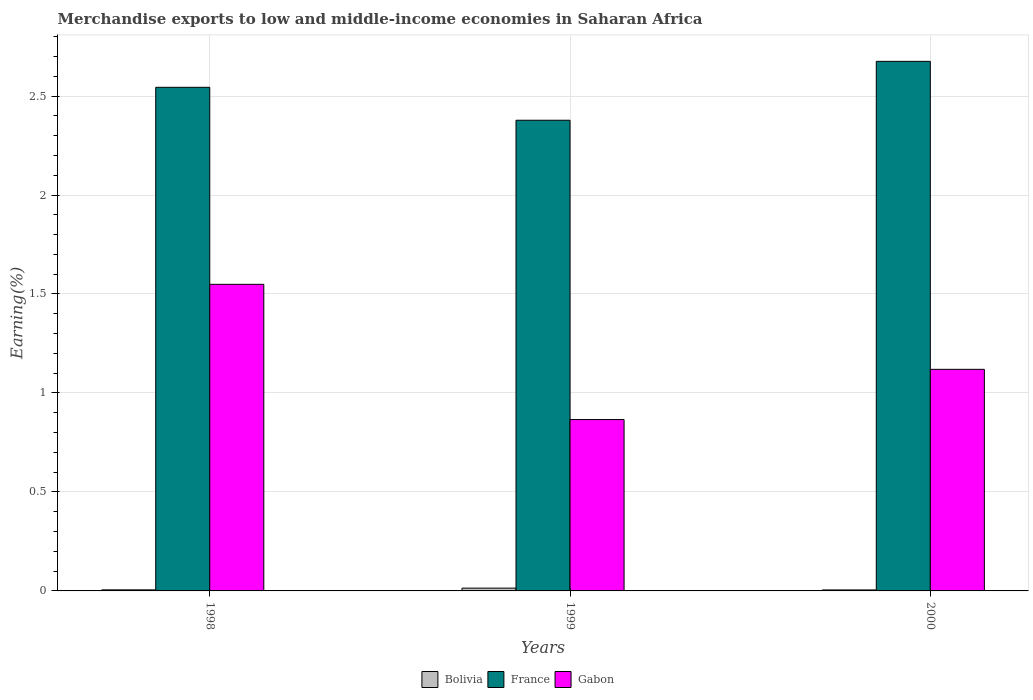How many groups of bars are there?
Keep it short and to the point. 3. How many bars are there on the 2nd tick from the right?
Provide a succinct answer. 3. What is the label of the 2nd group of bars from the left?
Give a very brief answer. 1999. In how many cases, is the number of bars for a given year not equal to the number of legend labels?
Provide a short and direct response. 0. What is the percentage of amount earned from merchandise exports in France in 1999?
Provide a short and direct response. 2.38. Across all years, what is the maximum percentage of amount earned from merchandise exports in Bolivia?
Give a very brief answer. 0.01. Across all years, what is the minimum percentage of amount earned from merchandise exports in France?
Your answer should be very brief. 2.38. In which year was the percentage of amount earned from merchandise exports in Bolivia maximum?
Offer a very short reply. 1999. In which year was the percentage of amount earned from merchandise exports in Gabon minimum?
Make the answer very short. 1999. What is the total percentage of amount earned from merchandise exports in Bolivia in the graph?
Provide a succinct answer. 0.02. What is the difference between the percentage of amount earned from merchandise exports in France in 1999 and that in 2000?
Offer a terse response. -0.3. What is the difference between the percentage of amount earned from merchandise exports in France in 2000 and the percentage of amount earned from merchandise exports in Gabon in 1998?
Ensure brevity in your answer.  1.13. What is the average percentage of amount earned from merchandise exports in Gabon per year?
Offer a terse response. 1.18. In the year 1998, what is the difference between the percentage of amount earned from merchandise exports in Gabon and percentage of amount earned from merchandise exports in Bolivia?
Your answer should be very brief. 1.54. What is the ratio of the percentage of amount earned from merchandise exports in France in 1998 to that in 1999?
Offer a terse response. 1.07. What is the difference between the highest and the second highest percentage of amount earned from merchandise exports in France?
Your answer should be very brief. 0.13. What is the difference between the highest and the lowest percentage of amount earned from merchandise exports in Gabon?
Your answer should be compact. 0.68. In how many years, is the percentage of amount earned from merchandise exports in Bolivia greater than the average percentage of amount earned from merchandise exports in Bolivia taken over all years?
Provide a succinct answer. 1. Is the sum of the percentage of amount earned from merchandise exports in France in 1999 and 2000 greater than the maximum percentage of amount earned from merchandise exports in Bolivia across all years?
Ensure brevity in your answer.  Yes. What does the 1st bar from the left in 1999 represents?
Your answer should be very brief. Bolivia. What does the 2nd bar from the right in 2000 represents?
Give a very brief answer. France. Is it the case that in every year, the sum of the percentage of amount earned from merchandise exports in France and percentage of amount earned from merchandise exports in Gabon is greater than the percentage of amount earned from merchandise exports in Bolivia?
Give a very brief answer. Yes. How many years are there in the graph?
Provide a succinct answer. 3. Does the graph contain any zero values?
Offer a very short reply. No. How many legend labels are there?
Your answer should be compact. 3. How are the legend labels stacked?
Ensure brevity in your answer.  Horizontal. What is the title of the graph?
Ensure brevity in your answer.  Merchandise exports to low and middle-income economies in Saharan Africa. What is the label or title of the Y-axis?
Give a very brief answer. Earning(%). What is the Earning(%) of Bolivia in 1998?
Offer a very short reply. 0.01. What is the Earning(%) in France in 1998?
Provide a short and direct response. 2.54. What is the Earning(%) of Gabon in 1998?
Provide a short and direct response. 1.55. What is the Earning(%) in Bolivia in 1999?
Provide a short and direct response. 0.01. What is the Earning(%) in France in 1999?
Keep it short and to the point. 2.38. What is the Earning(%) in Gabon in 1999?
Your response must be concise. 0.87. What is the Earning(%) in Bolivia in 2000?
Offer a terse response. 0.01. What is the Earning(%) of France in 2000?
Your answer should be compact. 2.68. What is the Earning(%) of Gabon in 2000?
Ensure brevity in your answer.  1.12. Across all years, what is the maximum Earning(%) of Bolivia?
Keep it short and to the point. 0.01. Across all years, what is the maximum Earning(%) in France?
Give a very brief answer. 2.68. Across all years, what is the maximum Earning(%) of Gabon?
Provide a succinct answer. 1.55. Across all years, what is the minimum Earning(%) in Bolivia?
Your answer should be compact. 0.01. Across all years, what is the minimum Earning(%) in France?
Provide a short and direct response. 2.38. Across all years, what is the minimum Earning(%) in Gabon?
Your answer should be compact. 0.87. What is the total Earning(%) of Bolivia in the graph?
Offer a very short reply. 0.02. What is the total Earning(%) of France in the graph?
Your answer should be very brief. 7.6. What is the total Earning(%) of Gabon in the graph?
Your response must be concise. 3.53. What is the difference between the Earning(%) in Bolivia in 1998 and that in 1999?
Offer a terse response. -0.01. What is the difference between the Earning(%) in France in 1998 and that in 1999?
Give a very brief answer. 0.17. What is the difference between the Earning(%) in Gabon in 1998 and that in 1999?
Give a very brief answer. 0.68. What is the difference between the Earning(%) in France in 1998 and that in 2000?
Offer a terse response. -0.13. What is the difference between the Earning(%) of Gabon in 1998 and that in 2000?
Keep it short and to the point. 0.43. What is the difference between the Earning(%) in Bolivia in 1999 and that in 2000?
Your answer should be compact. 0.01. What is the difference between the Earning(%) in France in 1999 and that in 2000?
Give a very brief answer. -0.3. What is the difference between the Earning(%) of Gabon in 1999 and that in 2000?
Offer a terse response. -0.25. What is the difference between the Earning(%) of Bolivia in 1998 and the Earning(%) of France in 1999?
Keep it short and to the point. -2.37. What is the difference between the Earning(%) in Bolivia in 1998 and the Earning(%) in Gabon in 1999?
Ensure brevity in your answer.  -0.86. What is the difference between the Earning(%) in France in 1998 and the Earning(%) in Gabon in 1999?
Keep it short and to the point. 1.68. What is the difference between the Earning(%) in Bolivia in 1998 and the Earning(%) in France in 2000?
Make the answer very short. -2.67. What is the difference between the Earning(%) of Bolivia in 1998 and the Earning(%) of Gabon in 2000?
Offer a very short reply. -1.11. What is the difference between the Earning(%) in France in 1998 and the Earning(%) in Gabon in 2000?
Your answer should be compact. 1.42. What is the difference between the Earning(%) in Bolivia in 1999 and the Earning(%) in France in 2000?
Your response must be concise. -2.66. What is the difference between the Earning(%) of Bolivia in 1999 and the Earning(%) of Gabon in 2000?
Provide a short and direct response. -1.11. What is the difference between the Earning(%) in France in 1999 and the Earning(%) in Gabon in 2000?
Provide a succinct answer. 1.26. What is the average Earning(%) in Bolivia per year?
Offer a terse response. 0.01. What is the average Earning(%) in France per year?
Your answer should be compact. 2.53. What is the average Earning(%) in Gabon per year?
Offer a very short reply. 1.18. In the year 1998, what is the difference between the Earning(%) in Bolivia and Earning(%) in France?
Ensure brevity in your answer.  -2.54. In the year 1998, what is the difference between the Earning(%) of Bolivia and Earning(%) of Gabon?
Offer a terse response. -1.54. In the year 1998, what is the difference between the Earning(%) in France and Earning(%) in Gabon?
Make the answer very short. 1. In the year 1999, what is the difference between the Earning(%) of Bolivia and Earning(%) of France?
Give a very brief answer. -2.36. In the year 1999, what is the difference between the Earning(%) of Bolivia and Earning(%) of Gabon?
Your answer should be very brief. -0.85. In the year 1999, what is the difference between the Earning(%) in France and Earning(%) in Gabon?
Make the answer very short. 1.51. In the year 2000, what is the difference between the Earning(%) of Bolivia and Earning(%) of France?
Make the answer very short. -2.67. In the year 2000, what is the difference between the Earning(%) in Bolivia and Earning(%) in Gabon?
Your answer should be compact. -1.11. In the year 2000, what is the difference between the Earning(%) of France and Earning(%) of Gabon?
Your response must be concise. 1.56. What is the ratio of the Earning(%) in Bolivia in 1998 to that in 1999?
Provide a succinct answer. 0.39. What is the ratio of the Earning(%) of France in 1998 to that in 1999?
Offer a terse response. 1.07. What is the ratio of the Earning(%) in Gabon in 1998 to that in 1999?
Offer a very short reply. 1.79. What is the ratio of the Earning(%) of Bolivia in 1998 to that in 2000?
Provide a succinct answer. 1.08. What is the ratio of the Earning(%) of France in 1998 to that in 2000?
Make the answer very short. 0.95. What is the ratio of the Earning(%) in Gabon in 1998 to that in 2000?
Make the answer very short. 1.38. What is the ratio of the Earning(%) of Bolivia in 1999 to that in 2000?
Make the answer very short. 2.81. What is the ratio of the Earning(%) in France in 1999 to that in 2000?
Your answer should be very brief. 0.89. What is the ratio of the Earning(%) in Gabon in 1999 to that in 2000?
Your answer should be compact. 0.77. What is the difference between the highest and the second highest Earning(%) of Bolivia?
Provide a succinct answer. 0.01. What is the difference between the highest and the second highest Earning(%) of France?
Provide a short and direct response. 0.13. What is the difference between the highest and the second highest Earning(%) of Gabon?
Ensure brevity in your answer.  0.43. What is the difference between the highest and the lowest Earning(%) in Bolivia?
Your response must be concise. 0.01. What is the difference between the highest and the lowest Earning(%) in France?
Your answer should be very brief. 0.3. What is the difference between the highest and the lowest Earning(%) of Gabon?
Provide a short and direct response. 0.68. 